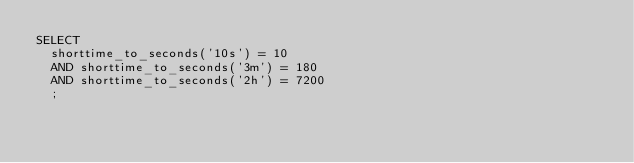Convert code to text. <code><loc_0><loc_0><loc_500><loc_500><_SQL_>SELECT 
  shorttime_to_seconds('10s') = 10
  AND shorttime_to_seconds('3m') = 180
  AND shorttime_to_seconds('2h') = 7200
  ;
</code> 